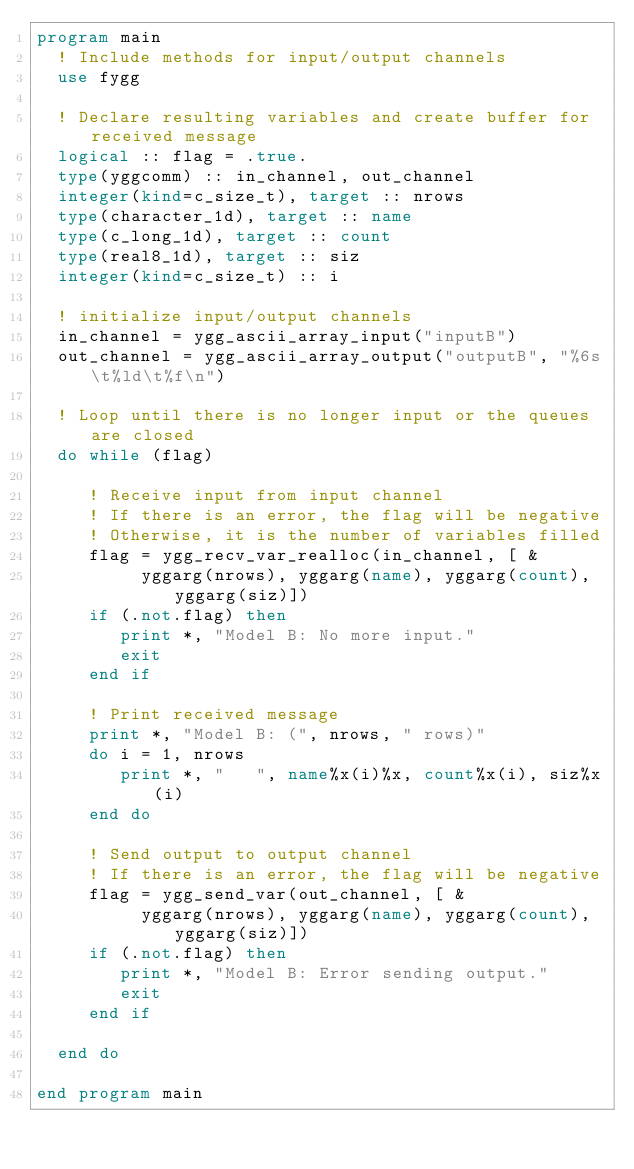Convert code to text. <code><loc_0><loc_0><loc_500><loc_500><_FORTRAN_>program main
  ! Include methods for input/output channels
  use fygg

  ! Declare resulting variables and create buffer for received message
  logical :: flag = .true.
  type(yggcomm) :: in_channel, out_channel
  integer(kind=c_size_t), target :: nrows
  type(character_1d), target :: name
  type(c_long_1d), target :: count
  type(real8_1d), target :: siz
  integer(kind=c_size_t) :: i

  ! initialize input/output channels
  in_channel = ygg_ascii_array_input("inputB")
  out_channel = ygg_ascii_array_output("outputB", "%6s\t%ld\t%f\n")

  ! Loop until there is no longer input or the queues are closed
  do while (flag)

     ! Receive input from input channel
     ! If there is an error, the flag will be negative
     ! Otherwise, it is the number of variables filled
     flag = ygg_recv_var_realloc(in_channel, [ &
          yggarg(nrows), yggarg(name), yggarg(count), yggarg(siz)])
     if (.not.flag) then
        print *, "Model B: No more input."
        exit
     end if

     ! Print received message
     print *, "Model B: (", nrows, " rows)"
     do i = 1, nrows
        print *, "   ", name%x(i)%x, count%x(i), siz%x(i)
     end do

     ! Send output to output channel
     ! If there is an error, the flag will be negative
     flag = ygg_send_var(out_channel, [ &
          yggarg(nrows), yggarg(name), yggarg(count), yggarg(siz)])
     if (.not.flag) then
        print *, "Model B: Error sending output."
        exit
     end if

  end do

end program main
</code> 